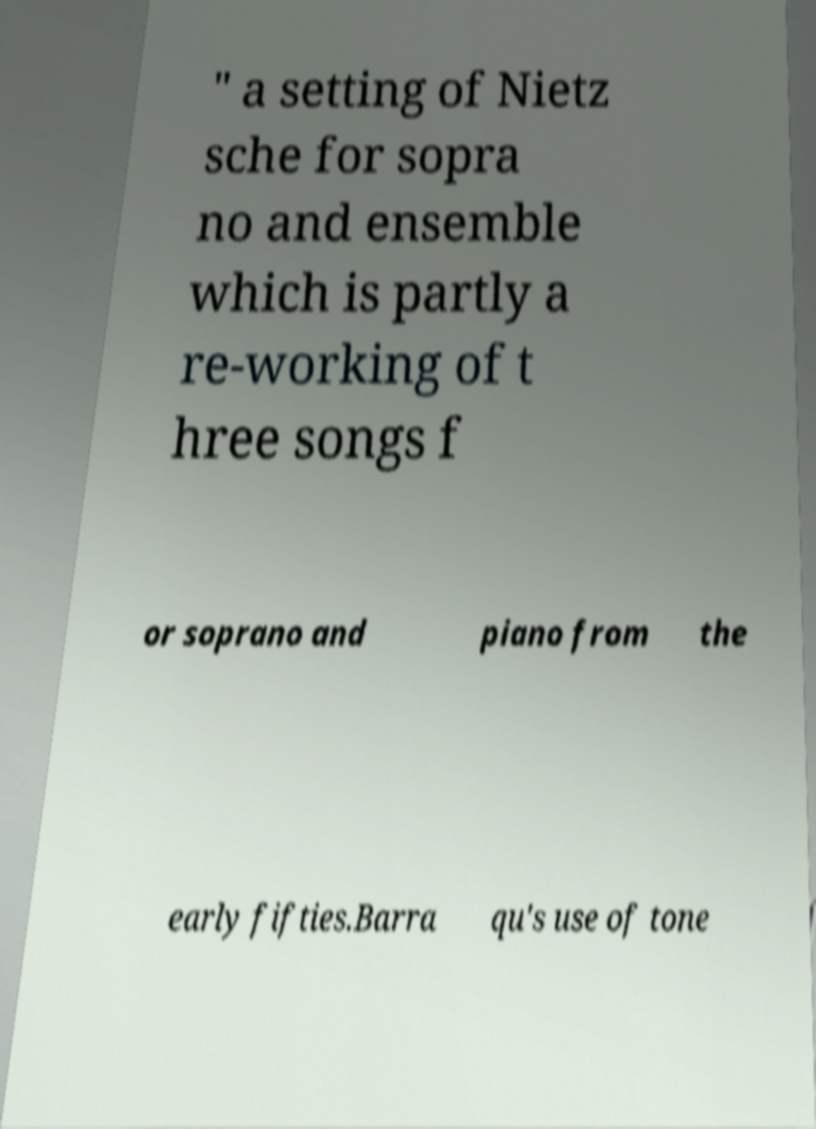Please read and relay the text visible in this image. What does it say? " a setting of Nietz sche for sopra no and ensemble which is partly a re-working of t hree songs f or soprano and piano from the early fifties.Barra qu's use of tone 